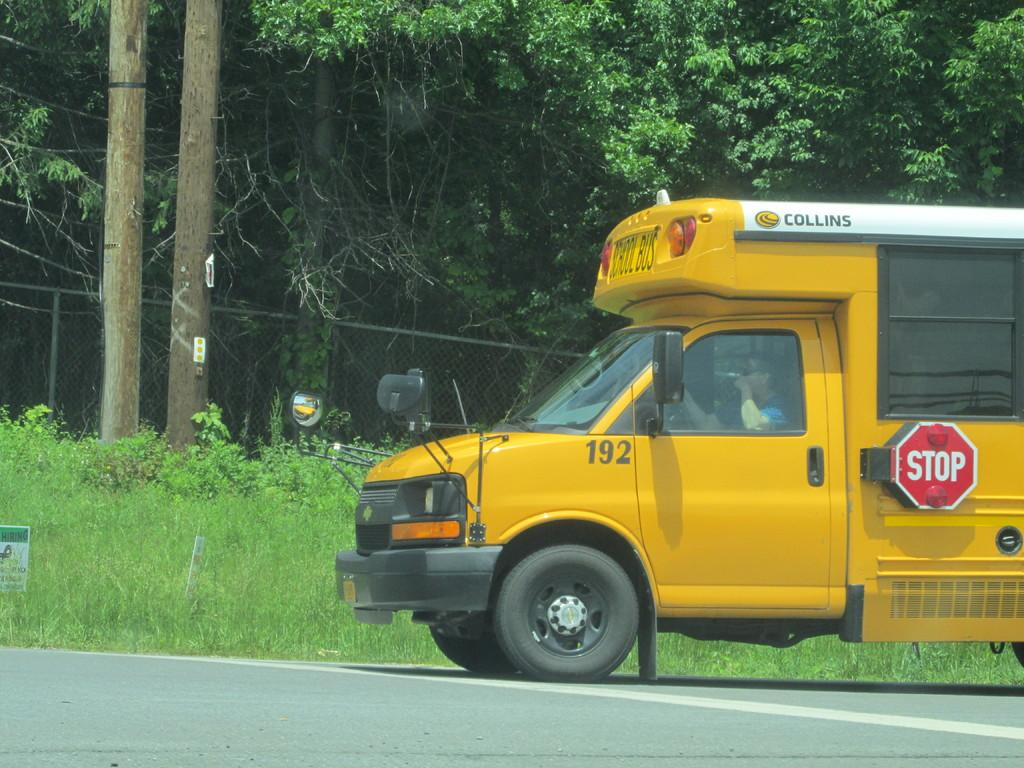What is on the road in the image? There is a vehicle on the road in the image. What can be seen in the distance in the image? There are trees and a fence in the background of the image. What else is present in the background of the image? There is a board in the background of the image. What type of vegetation covers the ground in the image? The ground is covered with grass at the bottom of the image. What activity is the daughter participating in with the rock in the image? There is no daughter or rock present in the image. 